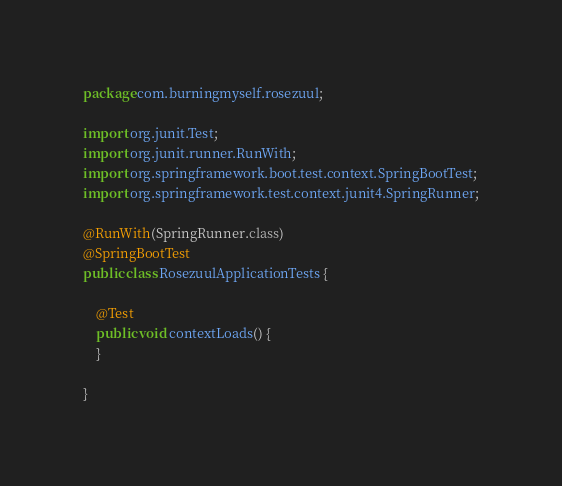<code> <loc_0><loc_0><loc_500><loc_500><_Java_>package com.burningmyself.rosezuul;

import org.junit.Test;
import org.junit.runner.RunWith;
import org.springframework.boot.test.context.SpringBootTest;
import org.springframework.test.context.junit4.SpringRunner;

@RunWith(SpringRunner.class)
@SpringBootTest
public class RosezuulApplicationTests {

    @Test
    public void contextLoads() {
    }

}
</code> 